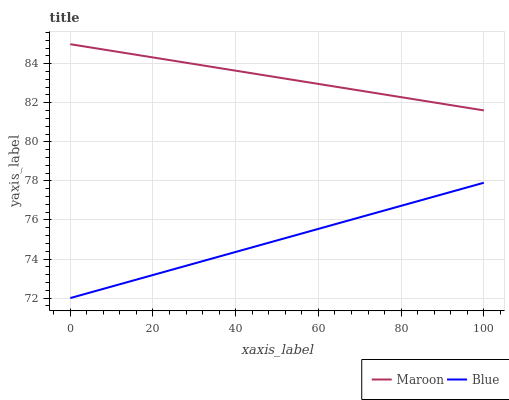Does Blue have the minimum area under the curve?
Answer yes or no. Yes. Does Maroon have the maximum area under the curve?
Answer yes or no. Yes. Does Maroon have the minimum area under the curve?
Answer yes or no. No. Is Blue the smoothest?
Answer yes or no. Yes. Is Maroon the roughest?
Answer yes or no. Yes. Is Maroon the smoothest?
Answer yes or no. No. Does Blue have the lowest value?
Answer yes or no. Yes. Does Maroon have the lowest value?
Answer yes or no. No. Does Maroon have the highest value?
Answer yes or no. Yes. Is Blue less than Maroon?
Answer yes or no. Yes. Is Maroon greater than Blue?
Answer yes or no. Yes. Does Blue intersect Maroon?
Answer yes or no. No. 